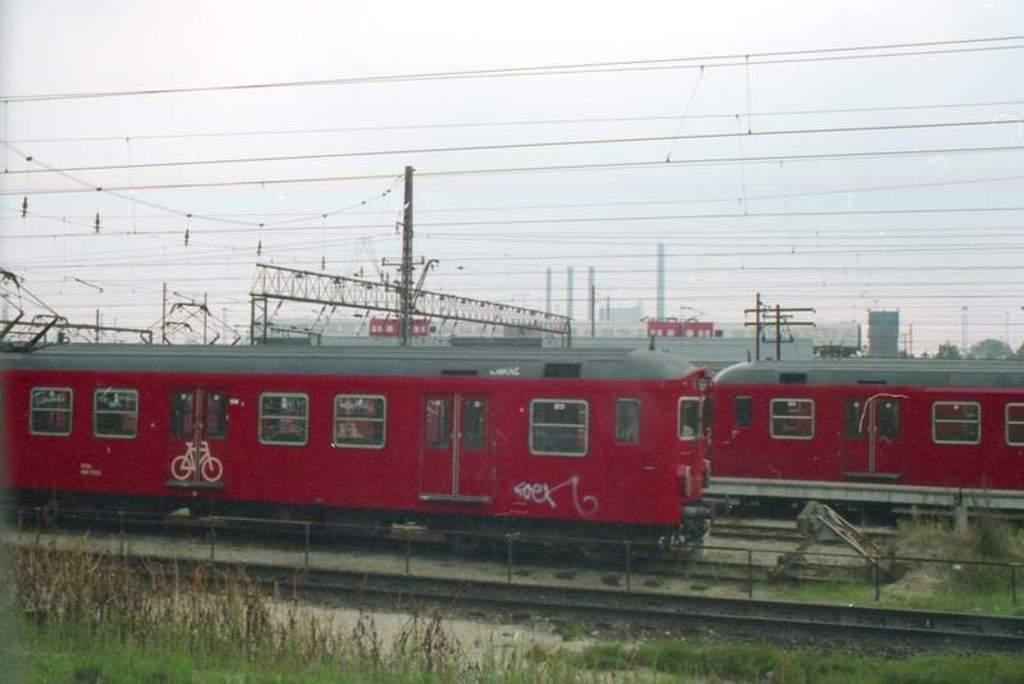Where was the image taken? The image was clicked outside. What type of terrain is visible at the bottom of the image? There is grass at the bottom of the image. What is the main subject in the middle of the image? There is a train in the middle of the image. What is the train positioned on in the image? There are railway tracks at the bottom of the image. What is visible at the top of the image? The sky is visible at the top of the image. What type of leaf is being used as a lipstick in the image? There is no leaf or lipstick present in the image. What type of produce is being harvested in the image? There is no produce or harvesting activity depicted in the image. 